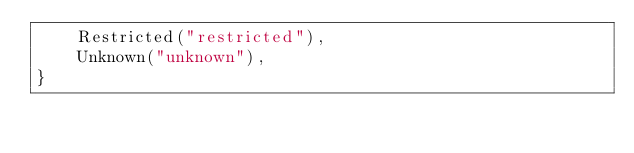<code> <loc_0><loc_0><loc_500><loc_500><_Kotlin_>    Restricted("restricted"),
    Unknown("unknown"),
}</code> 